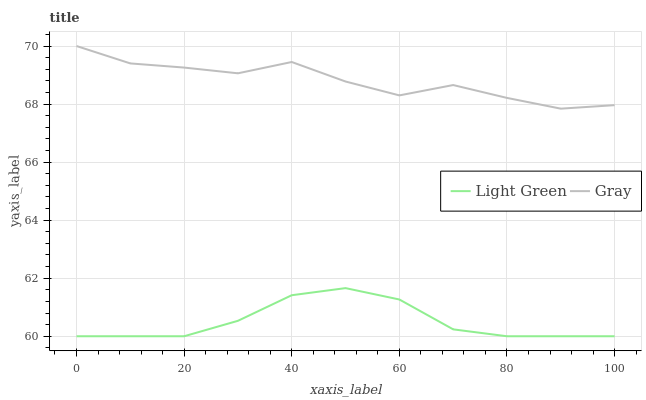Does Light Green have the minimum area under the curve?
Answer yes or no. Yes. Does Gray have the maximum area under the curve?
Answer yes or no. Yes. Does Light Green have the maximum area under the curve?
Answer yes or no. No. Is Light Green the smoothest?
Answer yes or no. Yes. Is Gray the roughest?
Answer yes or no. Yes. Is Light Green the roughest?
Answer yes or no. No. Does Light Green have the lowest value?
Answer yes or no. Yes. Does Gray have the highest value?
Answer yes or no. Yes. Does Light Green have the highest value?
Answer yes or no. No. Is Light Green less than Gray?
Answer yes or no. Yes. Is Gray greater than Light Green?
Answer yes or no. Yes. Does Light Green intersect Gray?
Answer yes or no. No. 